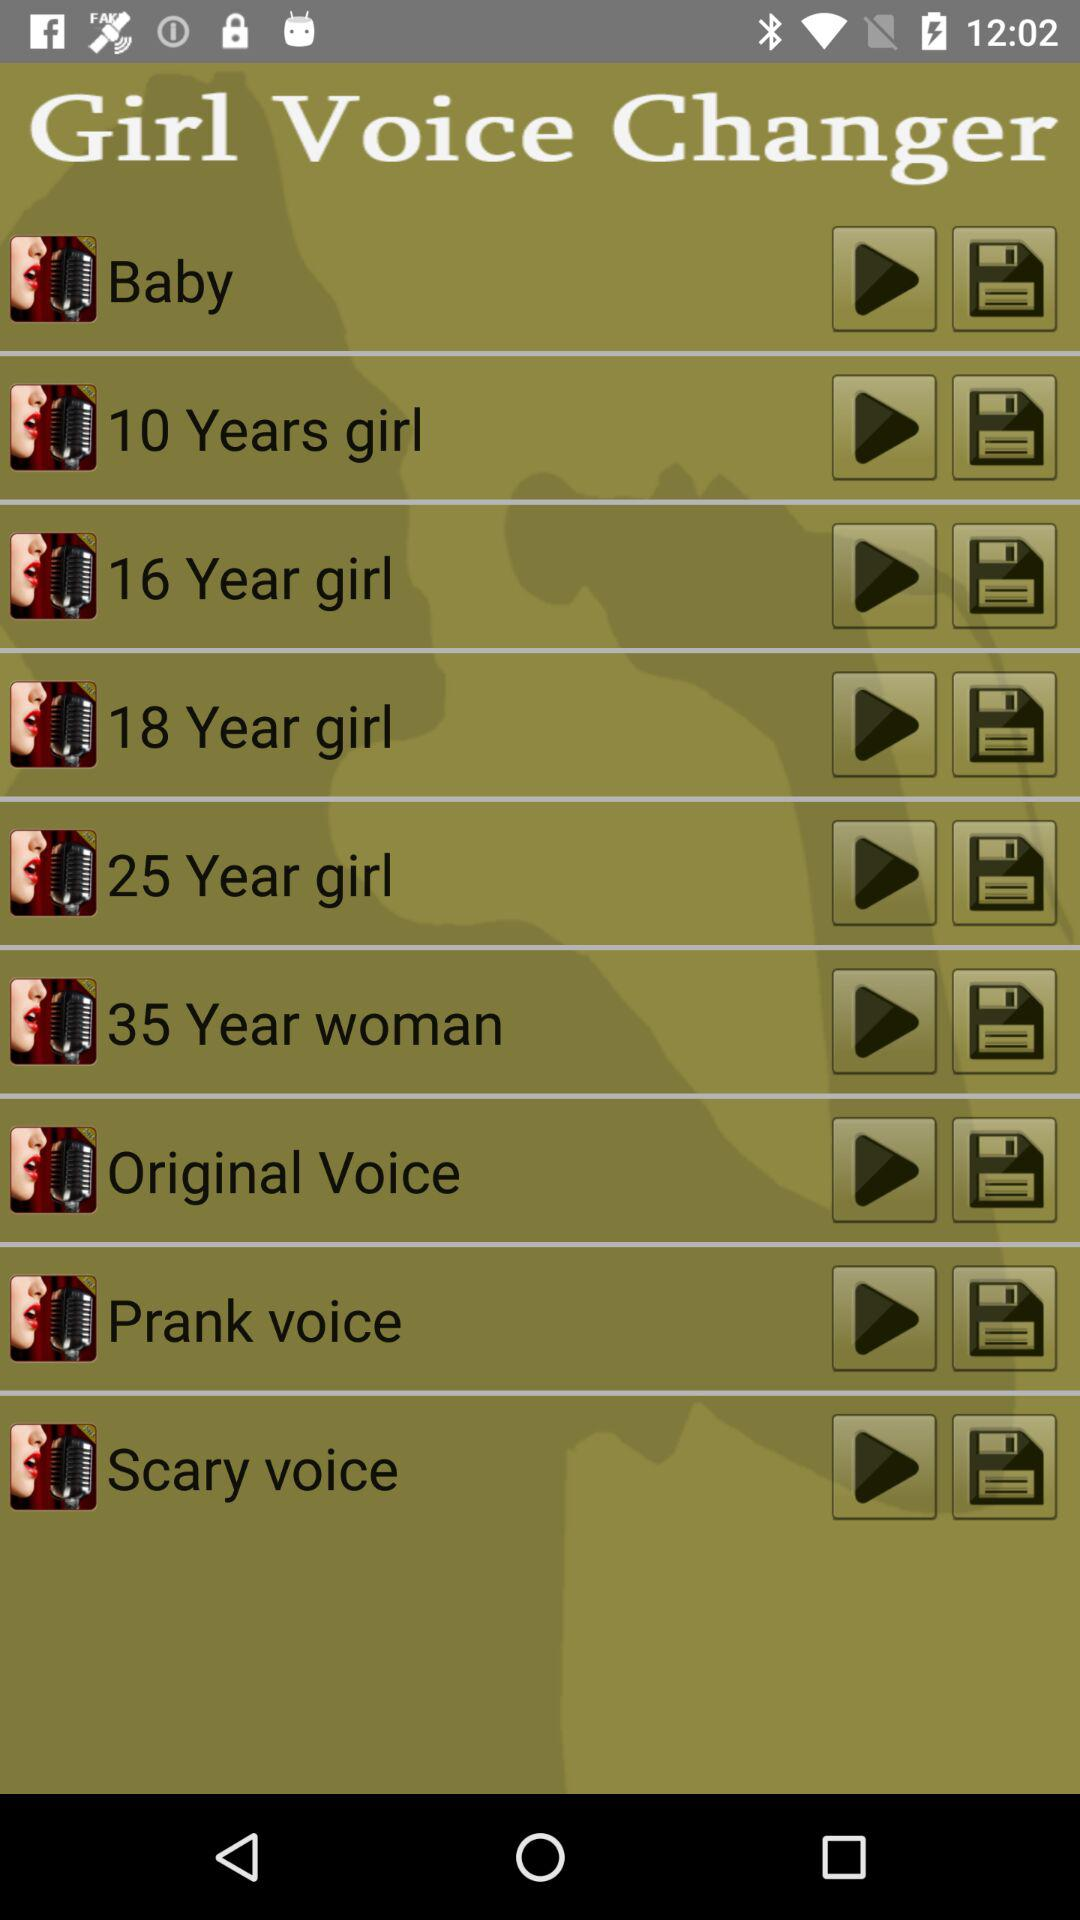How many voice effects are there?
Answer the question using a single word or phrase. 9 